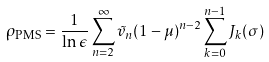Convert formula to latex. <formula><loc_0><loc_0><loc_500><loc_500>\rho _ { \text {PMS} } = \frac { 1 } { \ln \epsilon } \sum _ { n = 2 } ^ { \infty } \tilde { v } _ { n } ( 1 - \mu ) ^ { n - 2 } \sum _ { k = 0 } ^ { n - 1 } J _ { k } ( \sigma )</formula> 